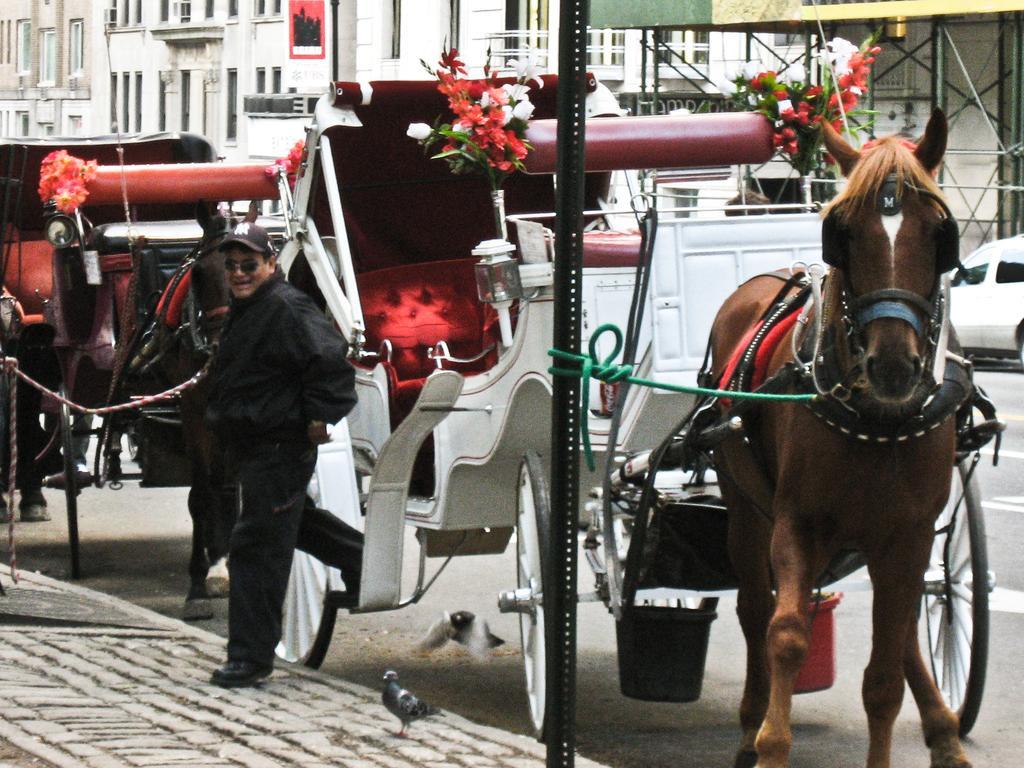In one or two sentences, can you explain what this image depicts? This image is taken outdoors. At the bottom of the image there is a road and a sidewalk. In the middle of the image there are two carts with horses and a man is standing on the sidewalk. There are two pigeons on the road. In the background there are a few buildings. 